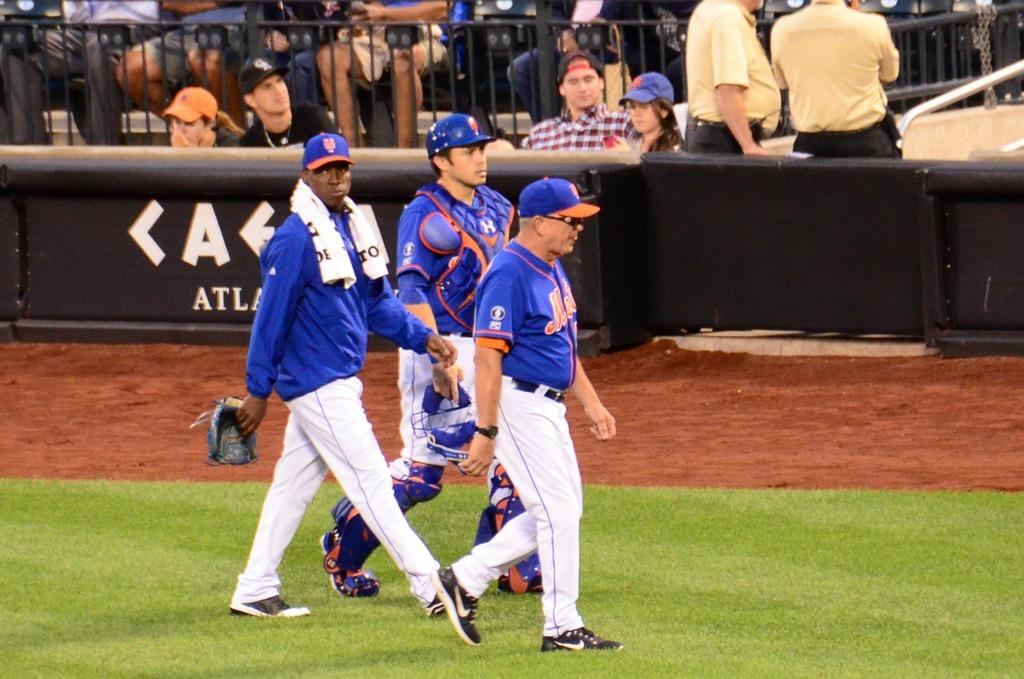<image>
Describe the image concisely. Three Mets athletes walking across the field while wearing blue shirts and hats.. 